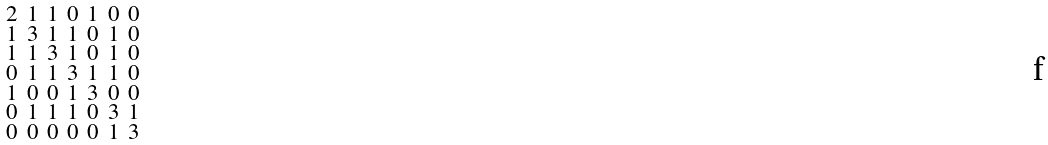Convert formula to latex. <formula><loc_0><loc_0><loc_500><loc_500>\begin{smallmatrix} 2 & 1 & 1 & 0 & 1 & 0 & 0 \\ 1 & 3 & 1 & 1 & 0 & 1 & 0 \\ 1 & 1 & 3 & 1 & 0 & 1 & 0 \\ 0 & 1 & 1 & 3 & 1 & 1 & 0 \\ 1 & 0 & 0 & 1 & 3 & 0 & 0 \\ 0 & 1 & 1 & 1 & 0 & 3 & 1 \\ 0 & 0 & 0 & 0 & 0 & 1 & 3 \end{smallmatrix}</formula> 